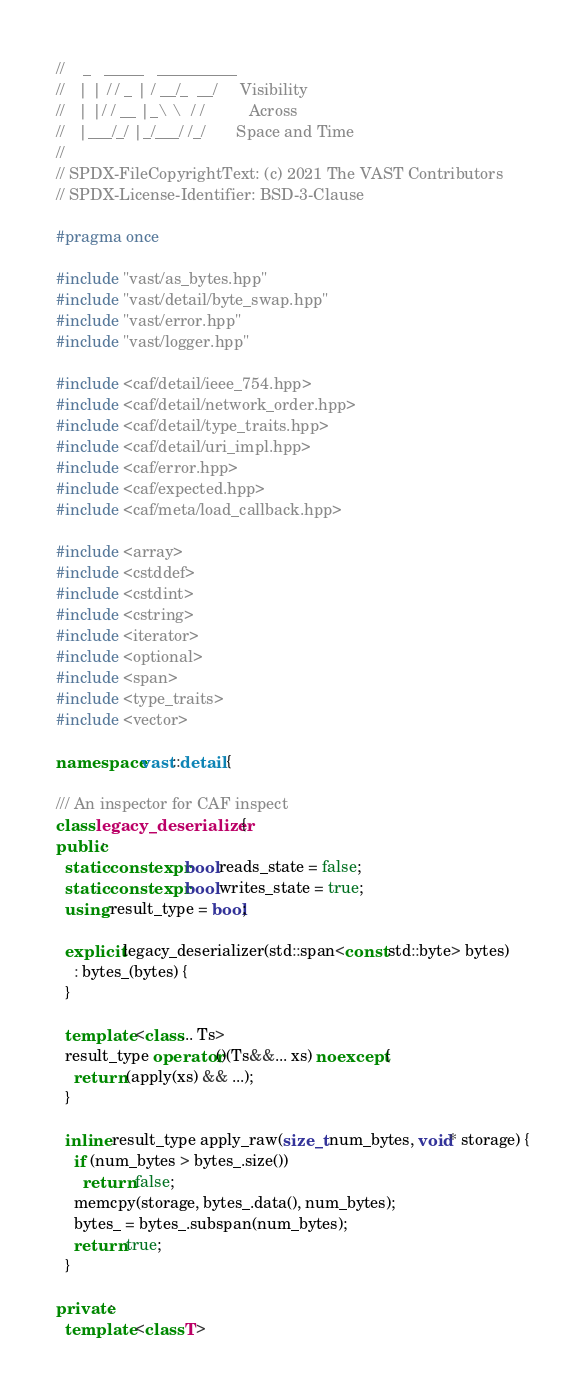<code> <loc_0><loc_0><loc_500><loc_500><_C++_>//    _   _____   __________
//   | | / / _ | / __/_  __/     Visibility
//   | |/ / __ |_\ \  / /          Across
//   |___/_/ |_/___/ /_/       Space and Time
//
// SPDX-FileCopyrightText: (c) 2021 The VAST Contributors
// SPDX-License-Identifier: BSD-3-Clause

#pragma once

#include "vast/as_bytes.hpp"
#include "vast/detail/byte_swap.hpp"
#include "vast/error.hpp"
#include "vast/logger.hpp"

#include <caf/detail/ieee_754.hpp>
#include <caf/detail/network_order.hpp>
#include <caf/detail/type_traits.hpp>
#include <caf/detail/uri_impl.hpp>
#include <caf/error.hpp>
#include <caf/expected.hpp>
#include <caf/meta/load_callback.hpp>

#include <array>
#include <cstddef>
#include <cstdint>
#include <cstring>
#include <iterator>
#include <optional>
#include <span>
#include <type_traits>
#include <vector>

namespace vast::detail {

/// An inspector for CAF inspect
class legacy_deserializer {
public:
  static constexpr bool reads_state = false;
  static constexpr bool writes_state = true;
  using result_type = bool;

  explicit legacy_deserializer(std::span<const std::byte> bytes)
    : bytes_(bytes) {
  }

  template <class... Ts>
  result_type operator()(Ts&&... xs) noexcept {
    return (apply(xs) && ...);
  }

  inline result_type apply_raw(size_t num_bytes, void* storage) {
    if (num_bytes > bytes_.size())
      return false;
    memcpy(storage, bytes_.data(), num_bytes);
    bytes_ = bytes_.subspan(num_bytes);
    return true;
  }

private:
  template <class T></code> 